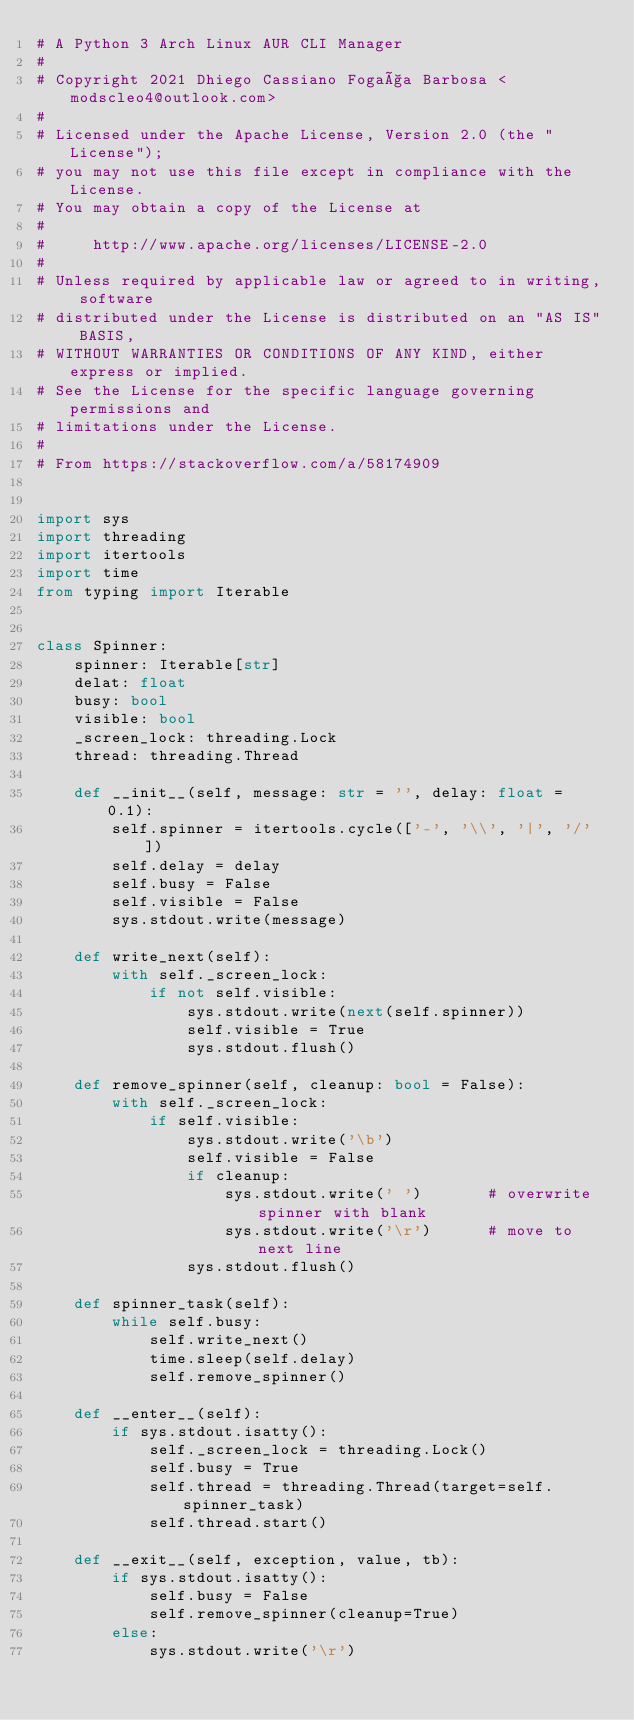<code> <loc_0><loc_0><loc_500><loc_500><_Python_># A Python 3 Arch Linux AUR CLI Manager
#
# Copyright 2021 Dhiego Cassiano Fogaça Barbosa <modscleo4@outlook.com>
#
# Licensed under the Apache License, Version 2.0 (the "License");
# you may not use this file except in compliance with the License.
# You may obtain a copy of the License at
#
#     http://www.apache.org/licenses/LICENSE-2.0
#
# Unless required by applicable law or agreed to in writing, software
# distributed under the License is distributed on an "AS IS" BASIS,
# WITHOUT WARRANTIES OR CONDITIONS OF ANY KIND, either express or implied.
# See the License for the specific language governing permissions and
# limitations under the License.
#
# From https://stackoverflow.com/a/58174909


import sys
import threading
import itertools
import time
from typing import Iterable


class Spinner:
    spinner: Iterable[str]
    delat: float
    busy: bool
    visible: bool
    _screen_lock: threading.Lock
    thread: threading.Thread

    def __init__(self, message: str = '', delay: float = 0.1):
        self.spinner = itertools.cycle(['-', '\\', '|', '/'])
        self.delay = delay
        self.busy = False
        self.visible = False
        sys.stdout.write(message)

    def write_next(self):
        with self._screen_lock:
            if not self.visible:
                sys.stdout.write(next(self.spinner))
                self.visible = True
                sys.stdout.flush()

    def remove_spinner(self, cleanup: bool = False):
        with self._screen_lock:
            if self.visible:
                sys.stdout.write('\b')
                self.visible = False
                if cleanup:
                    sys.stdout.write(' ')       # overwrite spinner with blank
                    sys.stdout.write('\r')      # move to next line
                sys.stdout.flush()

    def spinner_task(self):
        while self.busy:
            self.write_next()
            time.sleep(self.delay)
            self.remove_spinner()

    def __enter__(self):
        if sys.stdout.isatty():
            self._screen_lock = threading.Lock()
            self.busy = True
            self.thread = threading.Thread(target=self.spinner_task)
            self.thread.start()

    def __exit__(self, exception, value, tb):
        if sys.stdout.isatty():
            self.busy = False
            self.remove_spinner(cleanup=True)
        else:
            sys.stdout.write('\r')
</code> 